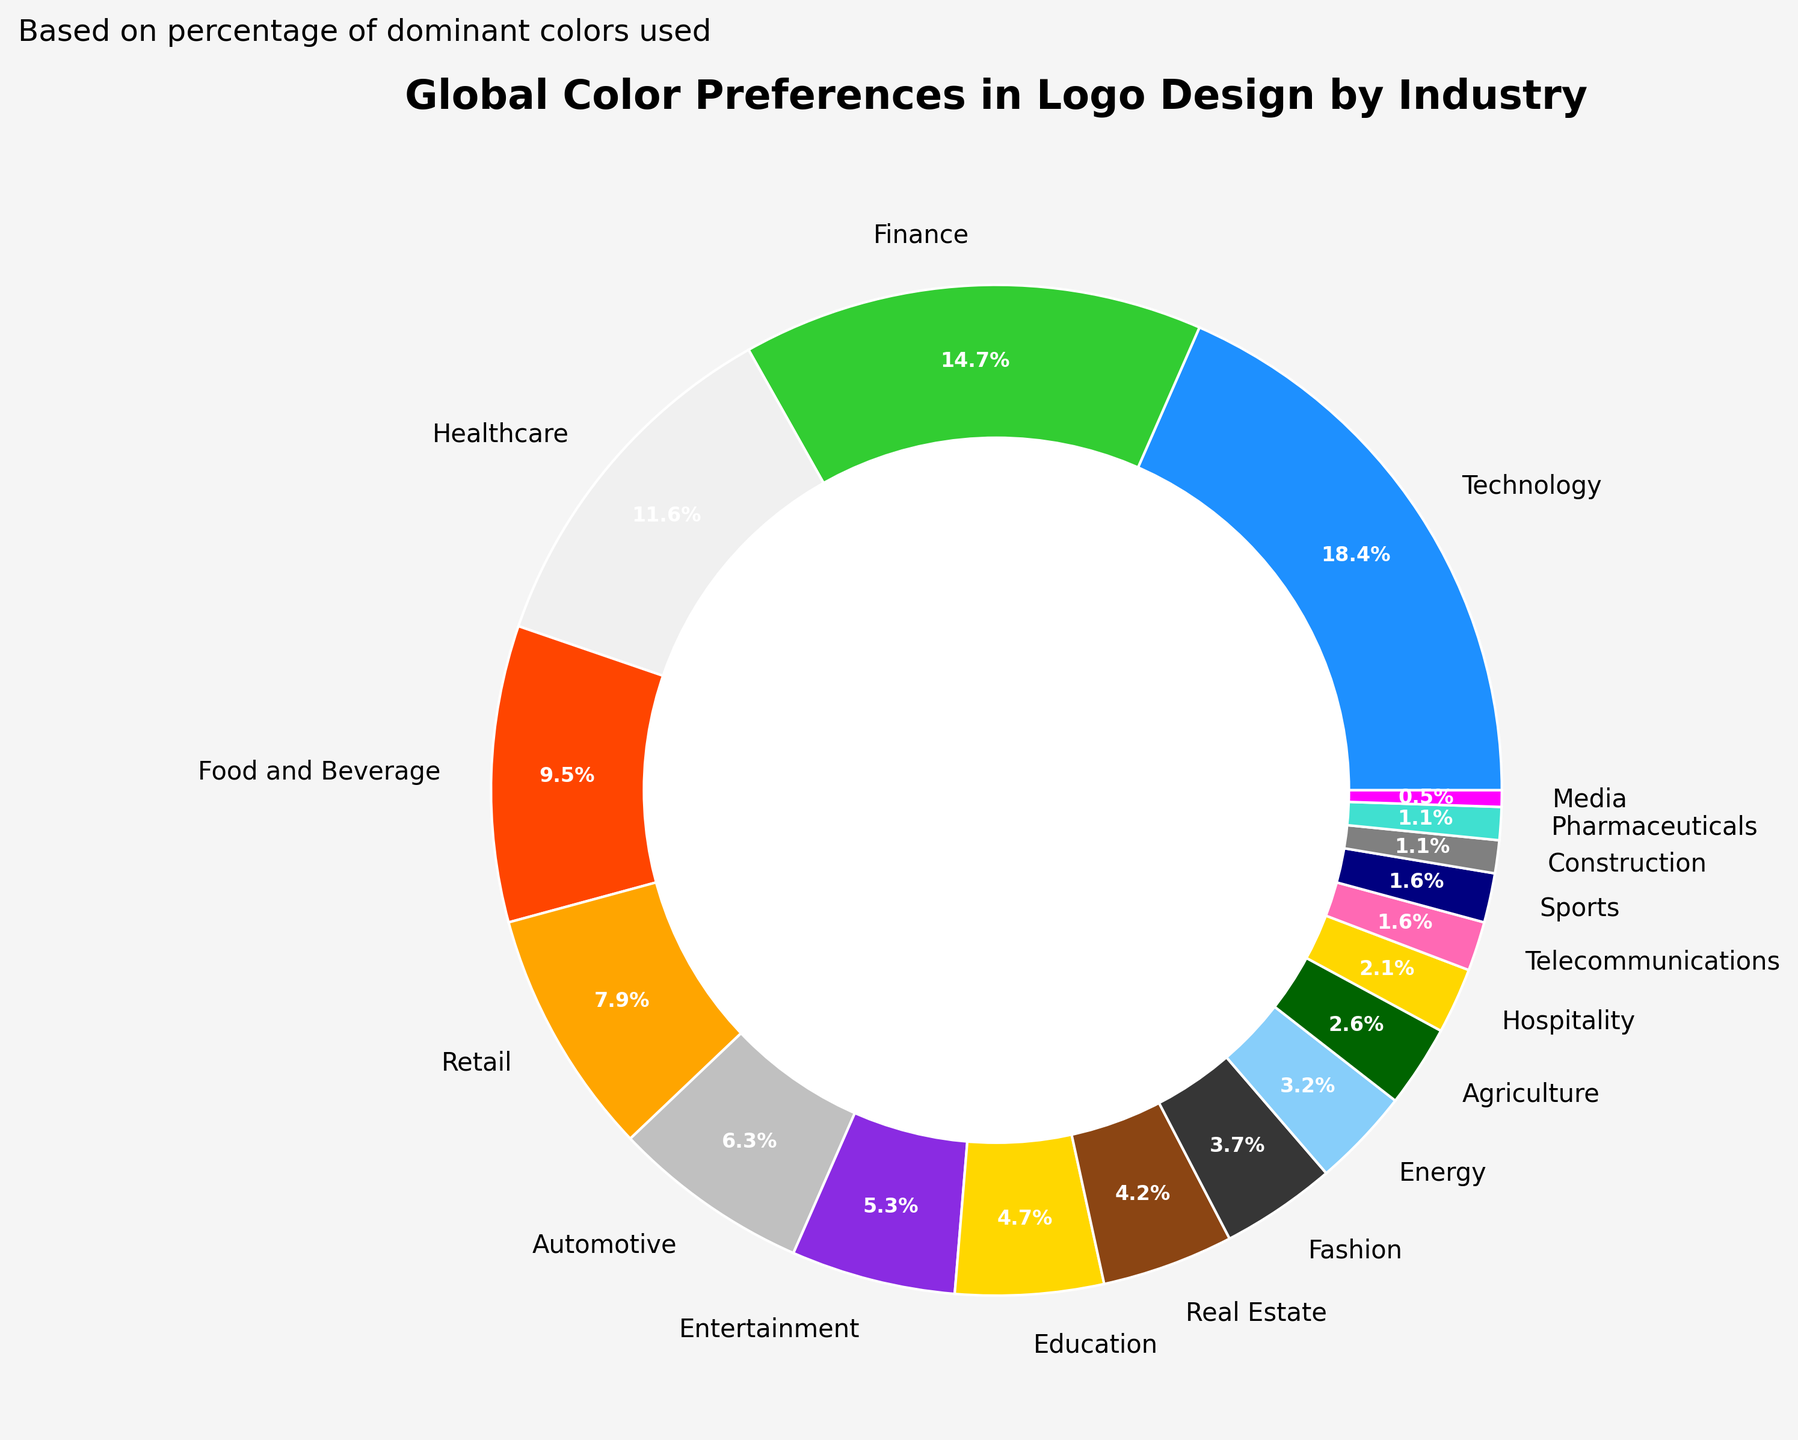Which industry sector uses the highest percentage of a single color in logo design? The figure shows a pie chart with different industry sectors and their corresponding color preferences. The sector with the largest slice (35%) is "Technology," and it uses the color blue.
Answer: Technology Which color is used least frequently across all industry sectors? By observing the pie chart, the smallest slice corresponds to the color magenta, which is used by "Media" at only 1%.
Answer: Magenta How many industry sectors use shades of blue (Blue, Light Blue, Navy Blue) as their dominant color? From the chart, we observe the slices corresponding to blue (Technology), light blue (Energy), and navy blue (Sports). There are 3 industry sectors.
Answer: 3 What is the combined percentage of industry sectors that use either green or dark green as their dominant color? The sectors using green are Finance (28%) and Agriculture (5%). Summing these percentages, 28 + 5 = 33.
Answer: 33% Compare the percentage use of red and orange in logo design. Which is more prevalent, and by how much? From the chart, red (Food and Beverage) is 18% and orange (Retail) is 15%. Subtracting the two, 18 - 15 = 3. Red is more prevalent by 3%.
Answer: Red by 3% What is the total percentage of industry sectors that use colors typically associated with neutral tones (White, Silver, Gray)? The chart shows white (Healthcare) at 22%, silver (Automotive) at 12%, and gray (Construction) at 2%. Summing them, 22 + 12 + 2 = 36%.
Answer: 36% Which two industry sectors have the closest percentages in color preference, and what are their percentages? From the pie chart, "Telecommunications" with pink (3%) and "Sports" with Navy Blue (3%) have equal percentages.
Answer: Telecommunications and Sports, 3% What is the percentage difference between the dominant color usage in the Fashion and Pharmaceutical sectors? The chart shows Fashion (Black) at 7% and Pharmaceuticals (Turquoise) at 2%. The difference is 7 - 2 = 5.
Answer: 5% Which three industry sectors combined make up less than 15% of the total? The chart shows the percentages for Hospitality (4%), Telecommunications (3%), and Sports (3%) adding up to 4 + 3 + 3 = 10%. Including Construction (2%) would make it 4 + 3 + 3 + 2 = 12%, which all together are less than 15%.
Answer: Hospitality, Telecommunications, Sports, Construction What's the total percentage of industry sectors using colors often associated with energy and nature (Green, Dark Green, Light Blue, Turquoise)? The chart shows Finance (Green) at 28%, Agriculture (Dark Green) at 5%, Energy (Light Blue) at 6%, and Pharmaceuticals (Turquoise) at 2%. Summing them, 28 + 5 + 6 + 2 = 41%.
Answer: 41% 